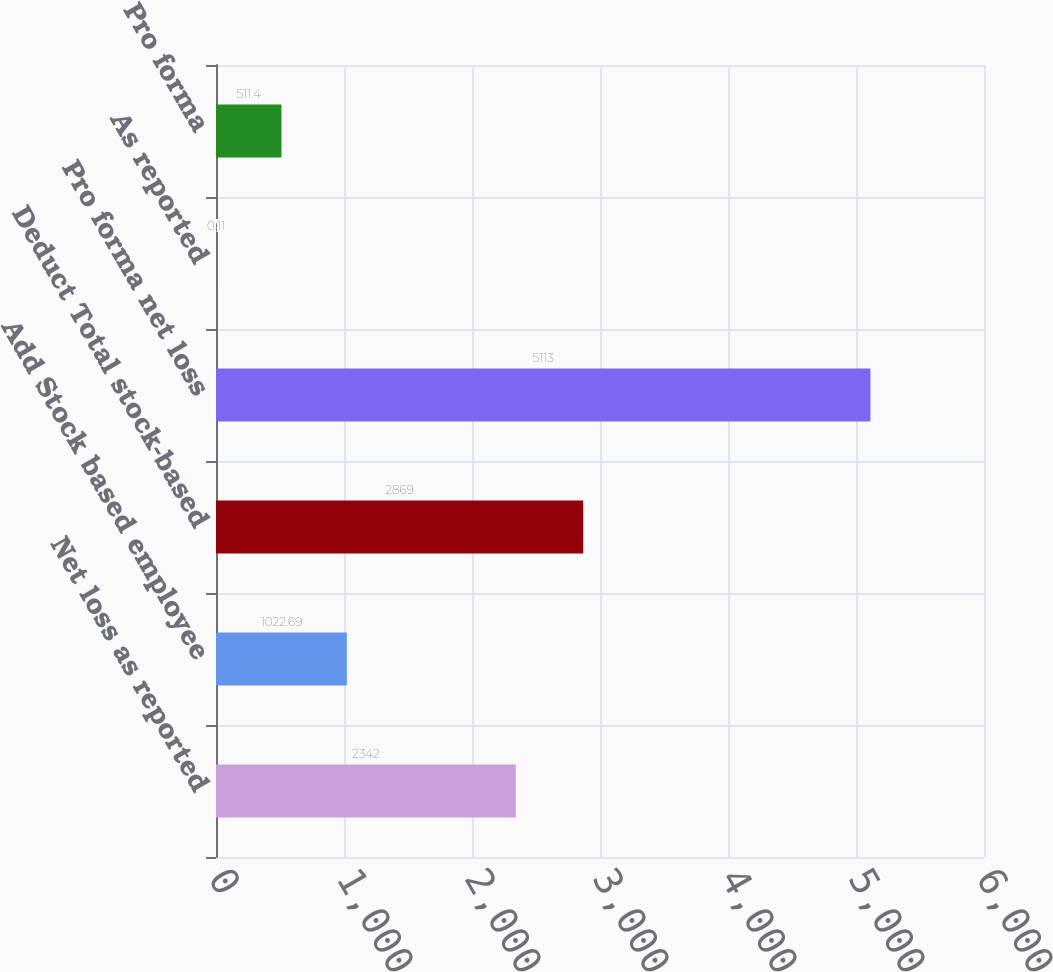<chart> <loc_0><loc_0><loc_500><loc_500><bar_chart><fcel>Net loss as reported<fcel>Add Stock based employee<fcel>Deduct Total stock-based<fcel>Pro forma net loss<fcel>As reported<fcel>Pro forma<nl><fcel>2342<fcel>1022.69<fcel>2869<fcel>5113<fcel>0.11<fcel>511.4<nl></chart> 